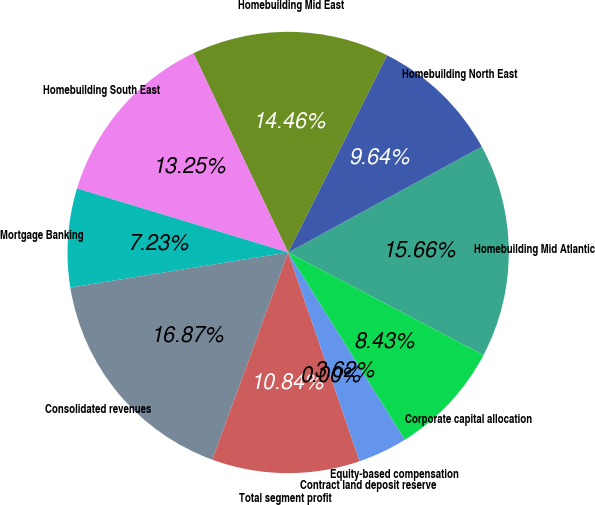<chart> <loc_0><loc_0><loc_500><loc_500><pie_chart><fcel>Homebuilding Mid Atlantic<fcel>Homebuilding North East<fcel>Homebuilding Mid East<fcel>Homebuilding South East<fcel>Mortgage Banking<fcel>Consolidated revenues<fcel>Total segment profit<fcel>Contract land deposit reserve<fcel>Equity-based compensation<fcel>Corporate capital allocation<nl><fcel>15.66%<fcel>9.64%<fcel>14.46%<fcel>13.25%<fcel>7.23%<fcel>16.87%<fcel>10.84%<fcel>0.0%<fcel>3.62%<fcel>8.43%<nl></chart> 